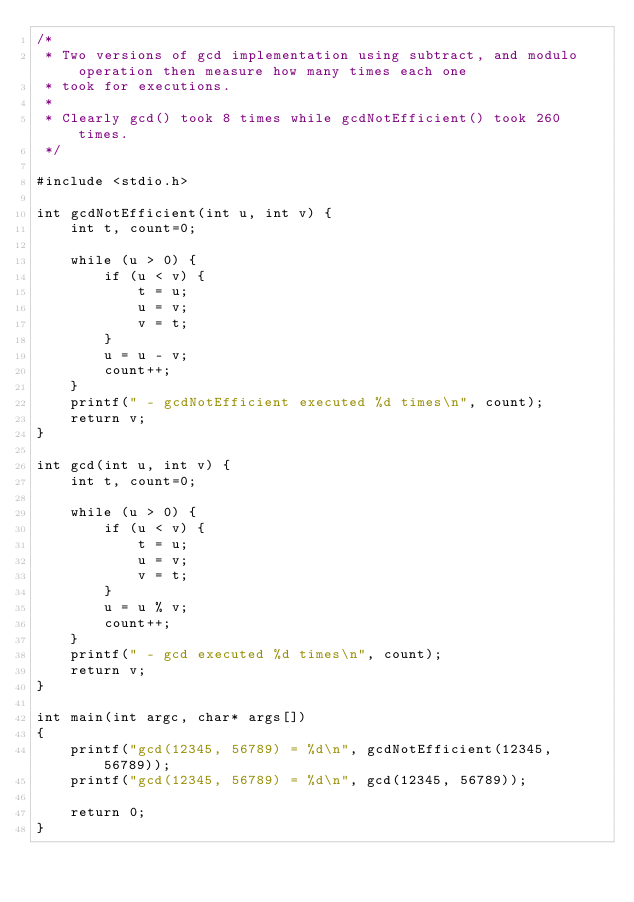<code> <loc_0><loc_0><loc_500><loc_500><_C_>/*
 * Two versions of gcd implementation using subtract, and modulo operation then measure how many times each one
 * took for executions.
 *
 * Clearly gcd() took 8 times while gcdNotEfficient() took 260 times.
 */

#include <stdio.h>

int gcdNotEfficient(int u, int v) {
	int t, count=0;
	
	while (u > 0) {
		if (u < v) {
			t = u;
			u = v;
			v = t;
		}
		u = u - v;
		count++;
	}
	printf(" - gcdNotEfficient executed %d times\n", count);
	return v;
}

int gcd(int u, int v) {
	int t, count=0;
	
	while (u > 0) {
		if (u < v) {
			t = u;
			u = v;
			v = t;
		}
		u = u % v;
		count++;
	}
	printf(" - gcd executed %d times\n", count);
	return v;
}

int main(int argc, char* args[])
{
	printf("gcd(12345, 56789) = %d\n", gcdNotEfficient(12345, 56789));
	printf("gcd(12345, 56789) = %d\n", gcd(12345, 56789));

	return 0;
}
</code> 